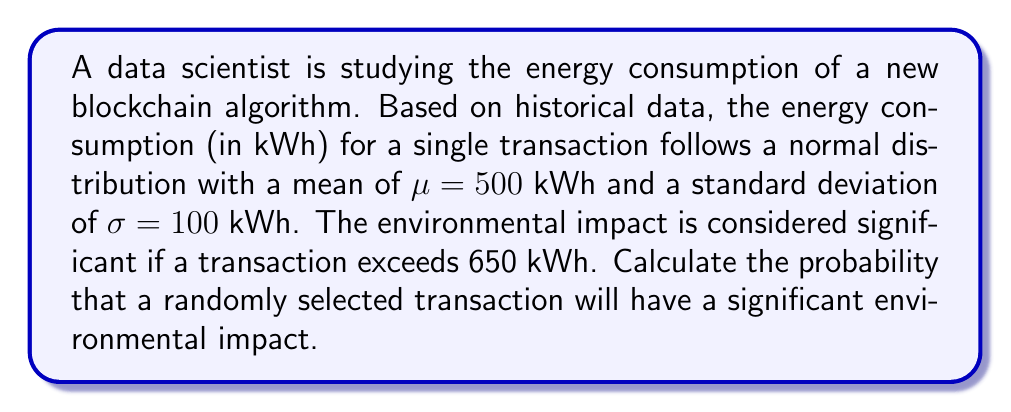Show me your answer to this math problem. To solve this problem, we need to use the properties of the normal distribution and calculate the z-score for the threshold value. Then, we can use the standard normal distribution table or a calculator to find the probability.

1. First, let's calculate the z-score for the threshold value:

   $$z = \frac{x - \mu}{\sigma}$$

   Where:
   $x$ = threshold value (650 kWh)
   $\mu$ = mean (500 kWh)
   $\sigma$ = standard deviation (100 kWh)

   $$z = \frac{650 - 500}{100} = \frac{150}{100} = 1.5$$

2. The z-score of 1.5 represents the number of standard deviations the threshold is above the mean.

3. We want to find the probability of a transaction exceeding this threshold, which is the area under the normal curve to the right of z = 1.5.

4. Using a standard normal distribution table or calculator, we can find that the area to the left of z = 1.5 is approximately 0.9332.

5. Since we want the area to the right, we subtract this value from 1:

   $$P(X > 650) = 1 - P(X \leq 650) = 1 - 0.9332 = 0.0668$$

Therefore, the probability that a randomly selected transaction will have a significant environmental impact (exceed 650 kWh) is approximately 0.0668 or 6.68%.
Answer: The probability that a randomly selected transaction will have a significant environmental impact is approximately 0.0668 or 6.68%. 